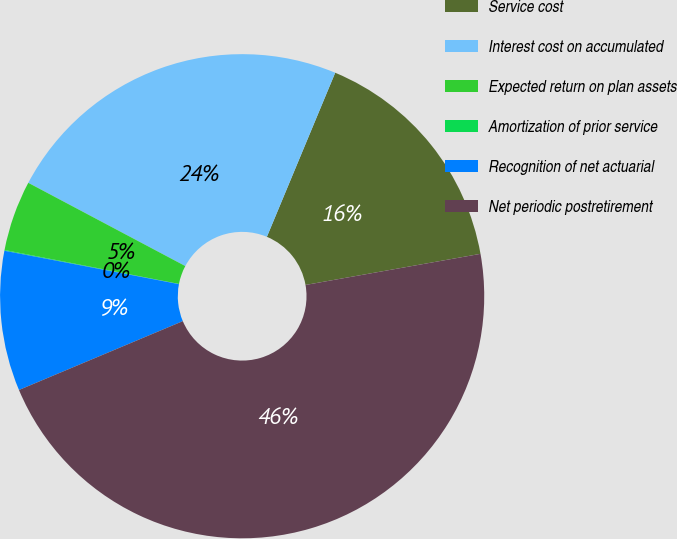Convert chart to OTSL. <chart><loc_0><loc_0><loc_500><loc_500><pie_chart><fcel>Service cost<fcel>Interest cost on accumulated<fcel>Expected return on plan assets<fcel>Amortization of prior service<fcel>Recognition of net actuarial<fcel>Net periodic postretirement<nl><fcel>15.92%<fcel>23.52%<fcel>4.7%<fcel>0.05%<fcel>9.34%<fcel>46.47%<nl></chart> 